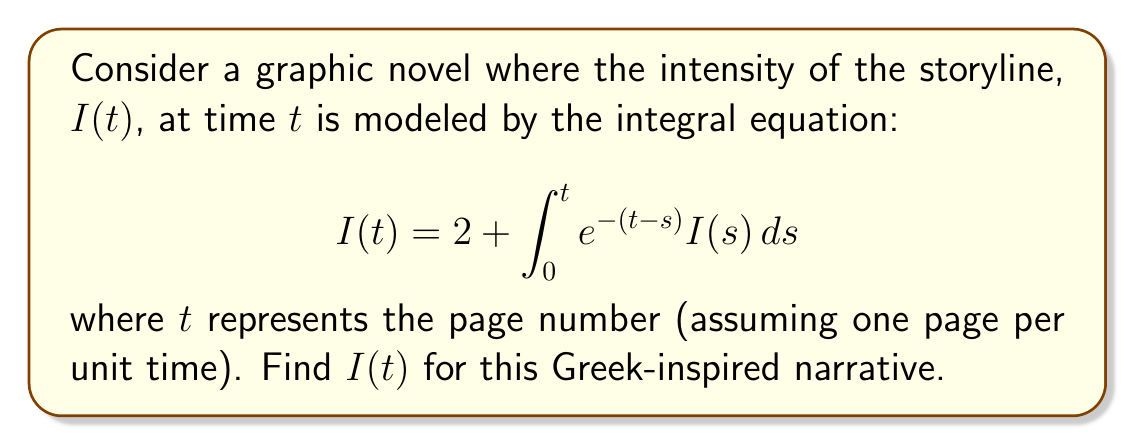What is the answer to this math problem? To solve this integral equation, we'll follow these steps:

1) First, we recognize this as a Volterra integral equation of the second kind.

2) We'll differentiate both sides with respect to $t$:

   $$\frac{d}{dt}I(t) = \frac{d}{dt}\left(2 + \int_0^t e^{-(t-s)} I(s) ds\right)$$

3) Using the Leibniz rule for differentiating integrals:

   $$I'(t) = e^{-(t-t)}I(t) + \int_0^t \frac{\partial}{\partial t}(e^{-(t-s)})I(s)ds$$

4) Simplify:

   $$I'(t) = I(t) - \int_0^t e^{-(t-s)}I(s)ds$$

5) Substitute the original equation:

   $$I'(t) = I(t) - (I(t) - 2)$$

6) Simplify:

   $$I'(t) = 2$$

7) This is a simple differential equation. Integrate both sides:

   $$I(t) = 2t + C$$

8) To find $C$, use the initial condition from the original equation at $t=0$:

   $$I(0) = 2 + \int_0^0 e^{-(0-s)} I(s) ds = 2$$

   So, $2 = C$

9) Therefore, the final solution is:

   $$I(t) = 2t + 2$$

This linear growth represents a steadily intensifying storyline, reminiscent of the narrative progression in Greek epics.
Answer: $I(t) = 2t + 2$ 